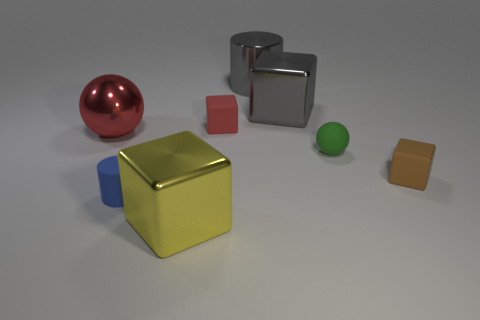What is the size of the sphere to the right of the big yellow metallic thing?
Offer a very short reply. Small. There is a matte cube that is on the left side of the tiny matte block that is to the right of the tiny sphere; what number of red shiny things are in front of it?
Your answer should be very brief. 1. What is the color of the ball on the left side of the gray thing that is to the right of the large gray cylinder?
Give a very brief answer. Red. Is there a purple thing that has the same size as the red metal ball?
Offer a very short reply. No. There is a large cube that is left of the small matte cube that is to the left of the cylinder behind the tiny blue rubber cylinder; what is its material?
Keep it short and to the point. Metal. There is a small rubber block in front of the small green matte object; what number of big cubes are in front of it?
Keep it short and to the point. 1. There is a metal object that is left of the yellow cube; is its size the same as the rubber sphere?
Offer a terse response. No. What number of green rubber things have the same shape as the big yellow metal thing?
Provide a succinct answer. 0. The large red metal thing is what shape?
Offer a terse response. Sphere. Is the number of tiny brown things that are behind the yellow block the same as the number of small balls?
Offer a terse response. Yes. 